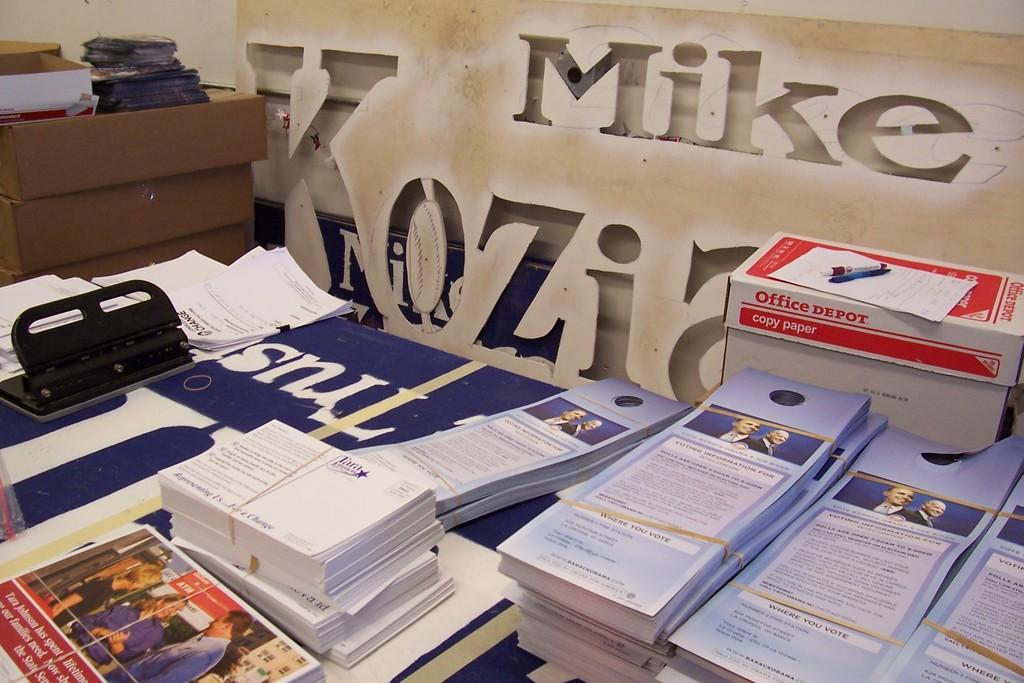<image>
Give a short and clear explanation of the subsequent image. a stack of papers in front of a office depot cardboard box 